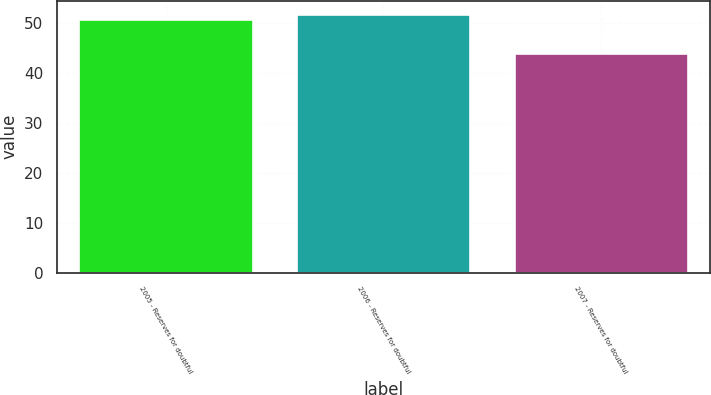Convert chart. <chart><loc_0><loc_0><loc_500><loc_500><bar_chart><fcel>2005 - Reserves for doubtful<fcel>2006 - Reserves for doubtful<fcel>2007 - Reserves for doubtful<nl><fcel>51<fcel>52<fcel>44<nl></chart> 